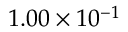<formula> <loc_0><loc_0><loc_500><loc_500>1 . 0 0 \times 1 0 ^ { - 1 }</formula> 